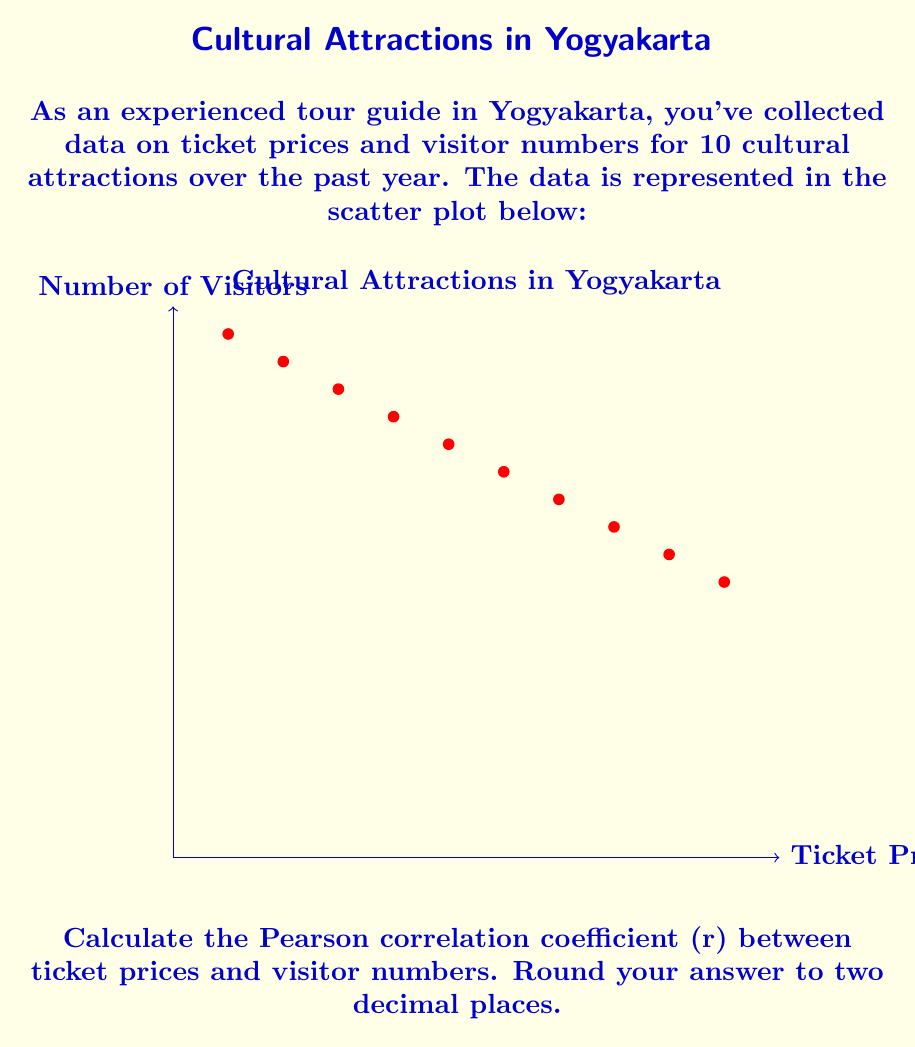Can you solve this math problem? To calculate the Pearson correlation coefficient (r), we'll use the formula:

$$ r = \frac{\sum_{i=1}^{n} (x_i - \bar{x})(y_i - \bar{y})}{\sqrt{\sum_{i=1}^{n} (x_i - \bar{x})^2 \sum_{i=1}^{n} (y_i - \bar{y})^2}} $$

Where:
$x_i$ = ticket prices
$y_i$ = visitor numbers
$\bar{x}$ = mean of ticket prices
$\bar{y}$ = mean of visitor numbers
$n$ = number of data points (10)

Step 1: Calculate means
$\bar{x} = \frac{10+15+20+25+30+35+40+45+50+55}{10} = 32.5$
$\bar{y} = \frac{950+900+850+800+750+700+650+600+550+500}{10} = 725$

Step 2: Calculate $(x_i - \bar{x})$, $(y_i - \bar{y})$, $(x_i - \bar{x})^2$, $(y_i - \bar{y})^2$, and $(x_i - \bar{x})(y_i - \bar{y})$

Step 3: Sum up the calculated values
$\sum (x_i - \bar{x})(y_i - \bar{y}) = -39375$
$\sum (x_i - \bar{x})^2 = 2062.5$
$\sum (y_i - \bar{y})^2 = 156250$

Step 4: Apply the formula
$$ r = \frac{-39375}{\sqrt{2062.5 \times 156250}} = -0.9999 $$

Step 5: Round to two decimal places
$r \approx -1.00$
Answer: $-1.00$ 